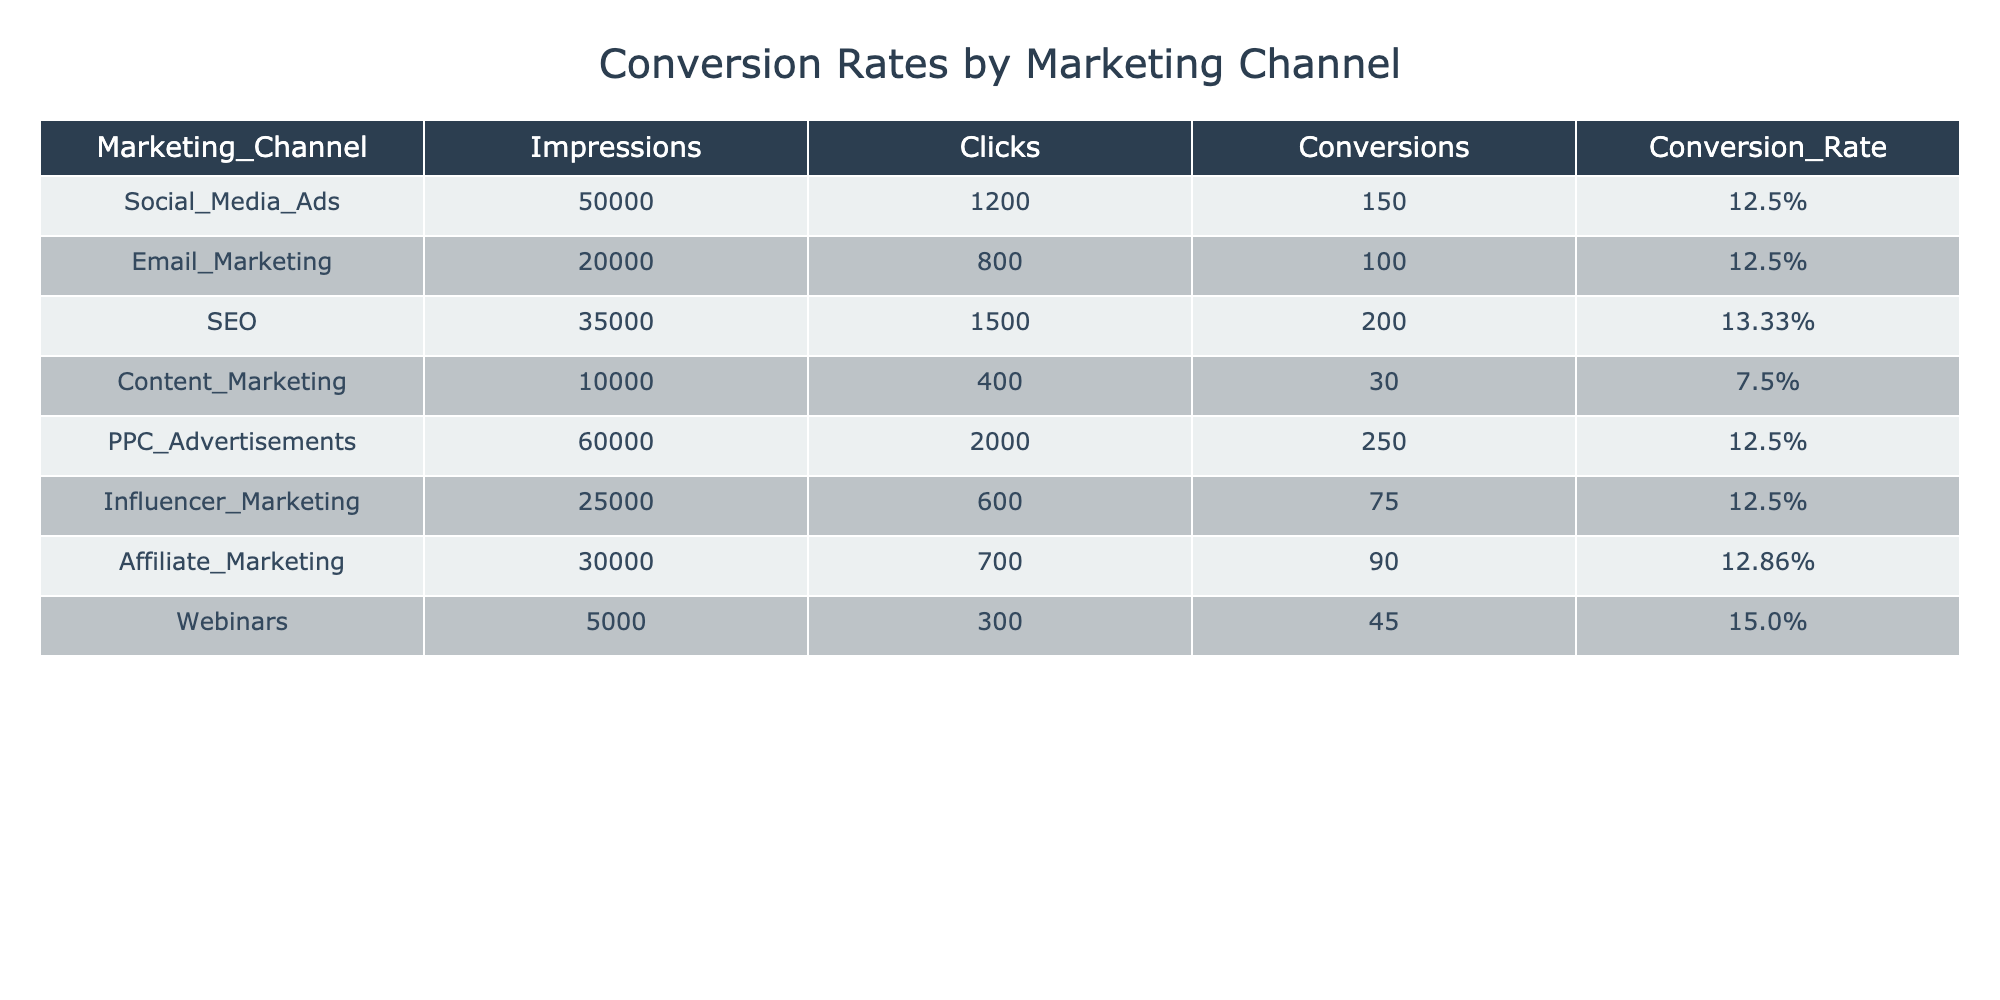What is the conversion rate for Email Marketing? The table shows that the conversion rate for Email Marketing is listed in the Conversion_Rate column for that specific channel, which is 12.5%.
Answer: 12.5% Which marketing channel had the highest conversion rate? By comparing the Conversion_Rate values in the table, Webinars have the highest conversion rate at 15.0%.
Answer: 15.0% What is the total number of conversions across all marketing channels? To find the total conversions, sum the Conversions column values: 150 + 100 + 200 + 30 + 250 + 75 + 90 + 45 = 940.
Answer: 940 Did PPC Advertisements have a lower conversion rate than SEO? Comparing the Conversion_Rate for PPC Advertisements (12.5%) and SEO (13.33%), PPC Advertisements had a lower conversion rate.
Answer: Yes What is the average conversion rate for Social Media Ads, Email Marketing, and Influencer Marketing? First, find their conversion rates: Social Media Ads (12.5%), Email Marketing (12.5%), Influencer Marketing (12.5%). Then, calculate the average: (12.5 + 12.5 + 12.5) / 3 = 12.5%.
Answer: 12.5% Which marketing channel had the most impressions, and what was its conversion rate? The channel with the most impressions is PPC Advertisements, which had 60,000 impressions. The corresponding conversion rate is 12.5%.
Answer: 12.5% How many more clicks did SEO receive compared to Content Marketing? The table lists SEO with 1500 clicks and Content Marketing with 400 clicks. The difference is: 1500 - 400 = 1100 more clicks for SEO.
Answer: 1100 Is the conversion rate for Affiliate Marketing higher than that for Content Marketing? The conversion rate for Affiliate Marketing is 12.86% and for Content Marketing is 7.5%, indicating that Affiliate Marketing has a higher conversion rate.
Answer: Yes What percentage of total impressions came from Social Media Ads and Email Marketing combined? Total impressions for Social Media Ads and Email Marketing are 50,000 + 20,000 = 70,000. The total impressions from all channels is 350,000 (sum of all impressions). Then, calculate the percentage: (70,000 / 350,000) * 100 = 20%.
Answer: 20% 